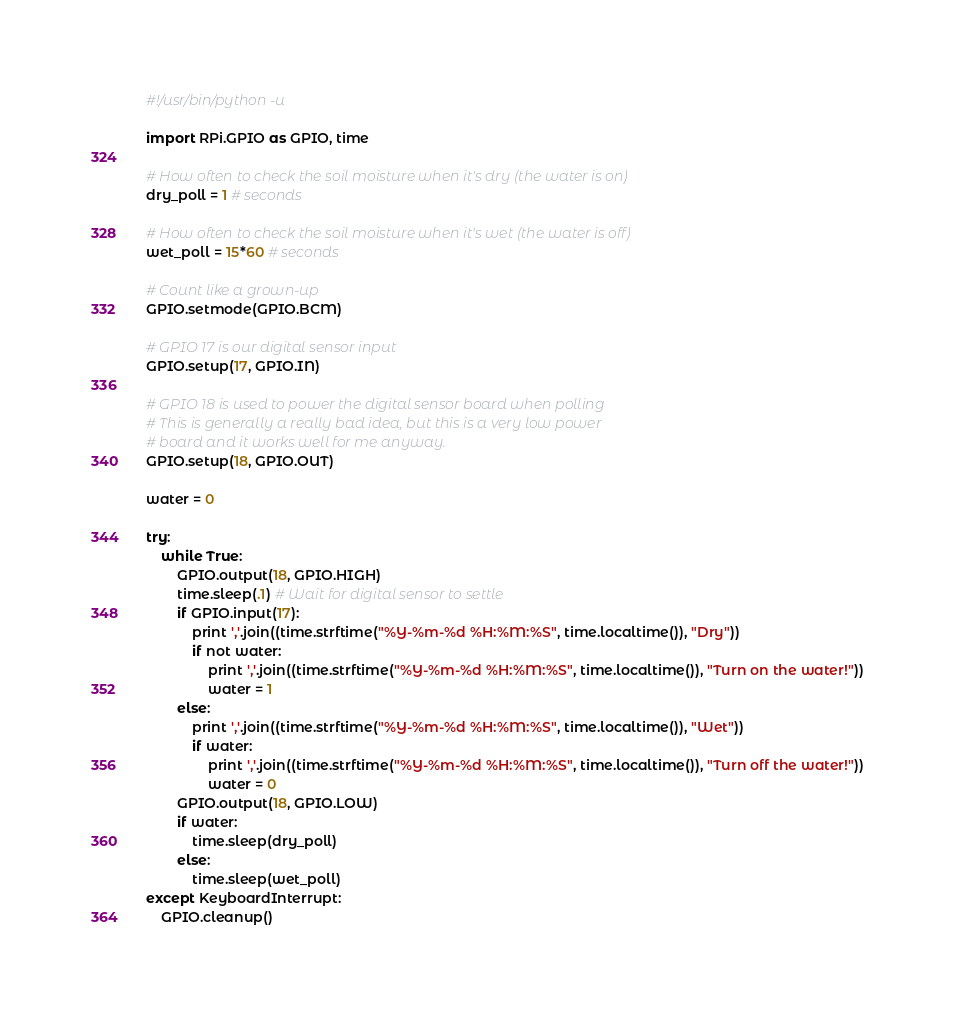Convert code to text. <code><loc_0><loc_0><loc_500><loc_500><_Python_>#!/usr/bin/python -u

import RPi.GPIO as GPIO, time 

# How often to check the soil moisture when it's dry (the water is on)
dry_poll = 1 # seconds

# How often to check the soil moisture when it's wet (the water is off)
wet_poll = 15*60 # seconds

# Count like a grown-up
GPIO.setmode(GPIO.BCM)

# GPIO 17 is our digital sensor input
GPIO.setup(17, GPIO.IN)

# GPIO 18 is used to power the digital sensor board when polling
# This is generally a really bad idea, but this is a very low power
# board and it works well for me anyway.
GPIO.setup(18, GPIO.OUT)

water = 0

try:
    while True:
        GPIO.output(18, GPIO.HIGH)
        time.sleep(.1) # Wait for digital sensor to settle
        if GPIO.input(17):
            print ','.join((time.strftime("%Y-%m-%d %H:%M:%S", time.localtime()), "Dry"))
            if not water:
                print ','.join((time.strftime("%Y-%m-%d %H:%M:%S", time.localtime()), "Turn on the water!"))
                water = 1
        else:
            print ','.join((time.strftime("%Y-%m-%d %H:%M:%S", time.localtime()), "Wet"))
            if water:
                print ','.join((time.strftime("%Y-%m-%d %H:%M:%S", time.localtime()), "Turn off the water!"))
                water = 0
        GPIO.output(18, GPIO.LOW)
        if water:
            time.sleep(dry_poll)
        else:
            time.sleep(wet_poll)
except KeyboardInterrupt:
    GPIO.cleanup()
</code> 